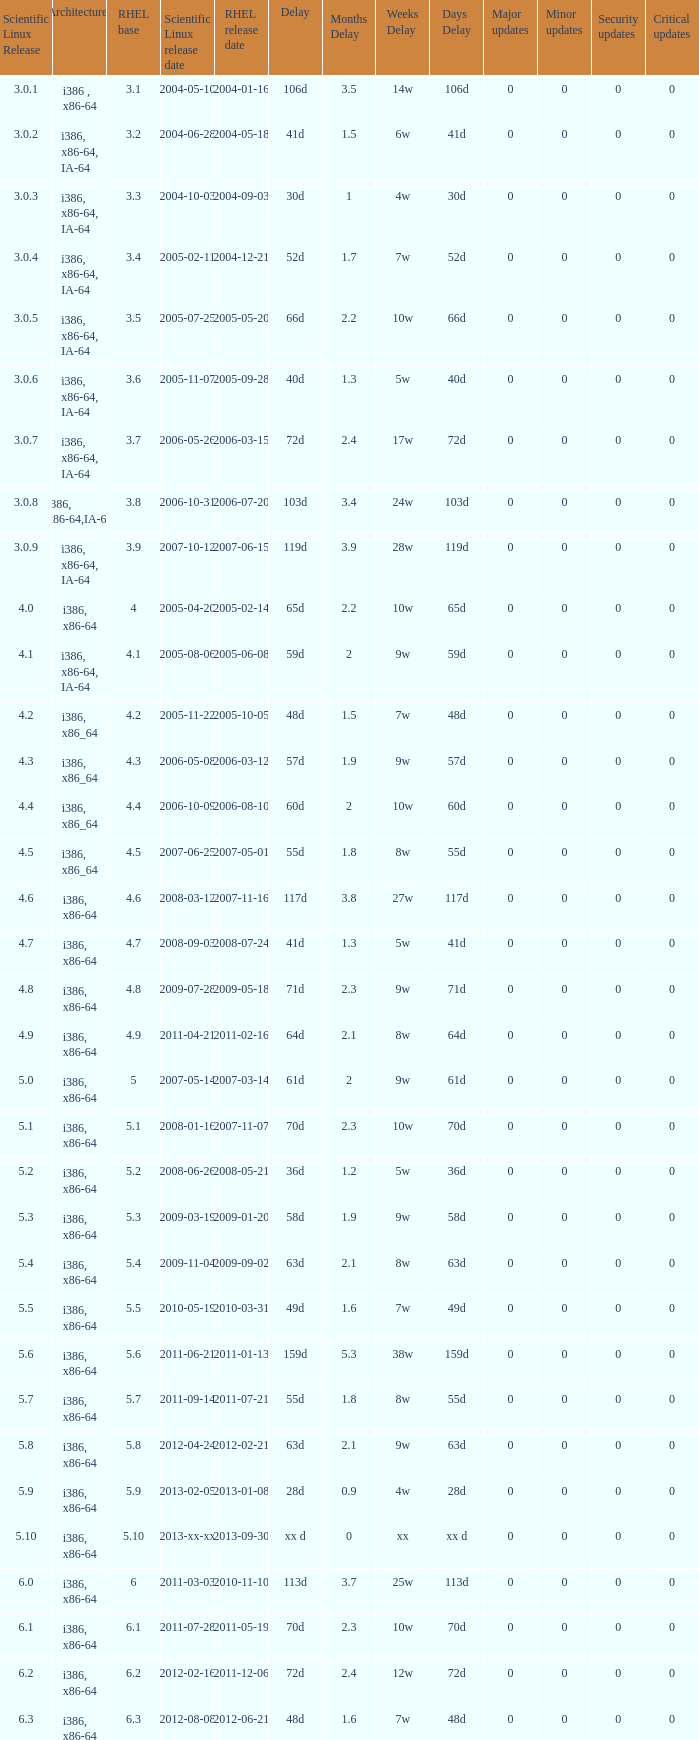Name the delay when scientific linux release is 5.10 Xx d. 